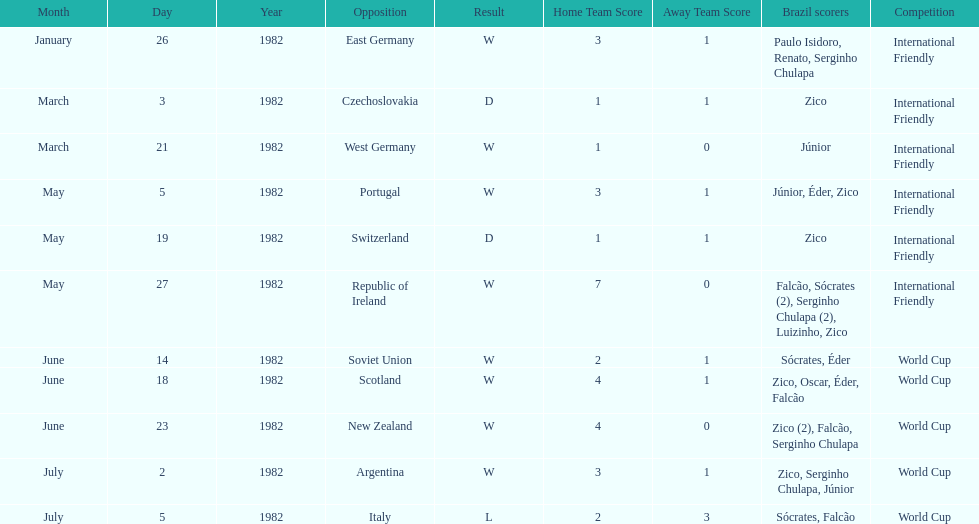Who won on january 26, 1982 and may 27, 1982? Brazil. 